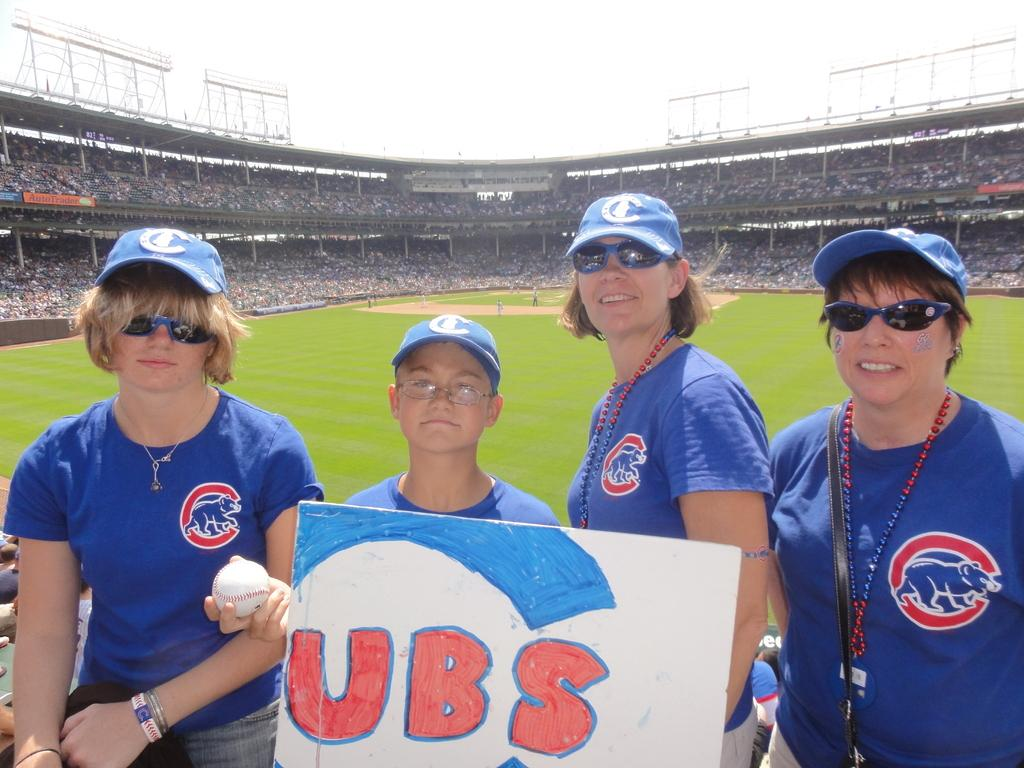<image>
Provide a brief description of the given image. A boy wearing a blue hat holds a sign for the Cubs baseball team 